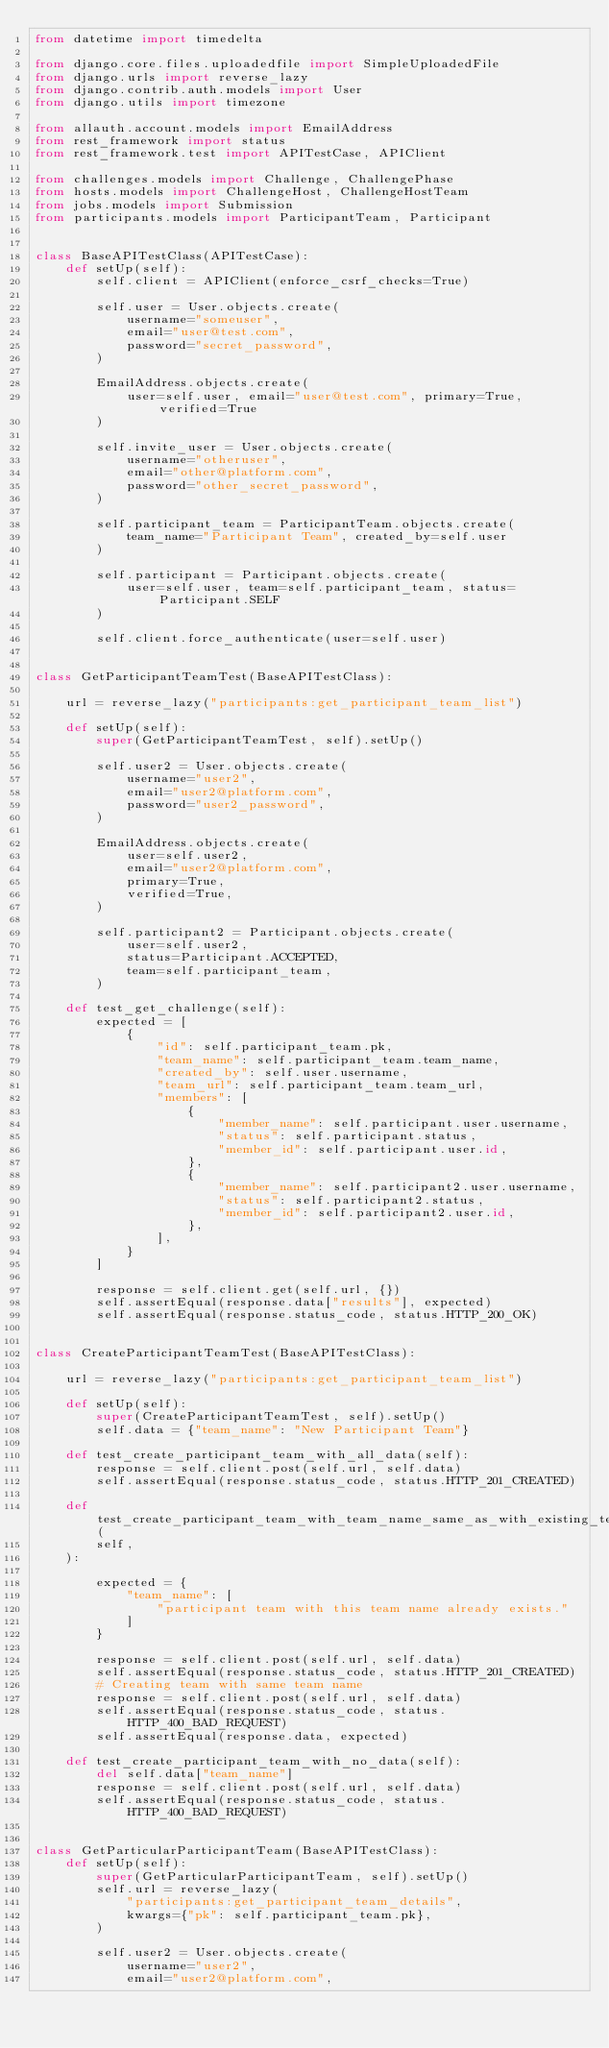Convert code to text. <code><loc_0><loc_0><loc_500><loc_500><_Python_>from datetime import timedelta

from django.core.files.uploadedfile import SimpleUploadedFile
from django.urls import reverse_lazy
from django.contrib.auth.models import User
from django.utils import timezone

from allauth.account.models import EmailAddress
from rest_framework import status
from rest_framework.test import APITestCase, APIClient

from challenges.models import Challenge, ChallengePhase
from hosts.models import ChallengeHost, ChallengeHostTeam
from jobs.models import Submission
from participants.models import ParticipantTeam, Participant


class BaseAPITestClass(APITestCase):
    def setUp(self):
        self.client = APIClient(enforce_csrf_checks=True)

        self.user = User.objects.create(
            username="someuser",
            email="user@test.com",
            password="secret_password",
        )

        EmailAddress.objects.create(
            user=self.user, email="user@test.com", primary=True, verified=True
        )

        self.invite_user = User.objects.create(
            username="otheruser",
            email="other@platform.com",
            password="other_secret_password",
        )

        self.participant_team = ParticipantTeam.objects.create(
            team_name="Participant Team", created_by=self.user
        )

        self.participant = Participant.objects.create(
            user=self.user, team=self.participant_team, status=Participant.SELF
        )

        self.client.force_authenticate(user=self.user)


class GetParticipantTeamTest(BaseAPITestClass):

    url = reverse_lazy("participants:get_participant_team_list")

    def setUp(self):
        super(GetParticipantTeamTest, self).setUp()

        self.user2 = User.objects.create(
            username="user2",
            email="user2@platform.com",
            password="user2_password",
        )

        EmailAddress.objects.create(
            user=self.user2,
            email="user2@platform.com",
            primary=True,
            verified=True,
        )

        self.participant2 = Participant.objects.create(
            user=self.user2,
            status=Participant.ACCEPTED,
            team=self.participant_team,
        )

    def test_get_challenge(self):
        expected = [
            {
                "id": self.participant_team.pk,
                "team_name": self.participant_team.team_name,
                "created_by": self.user.username,
                "team_url": self.participant_team.team_url,
                "members": [
                    {
                        "member_name": self.participant.user.username,
                        "status": self.participant.status,
                        "member_id": self.participant.user.id,
                    },
                    {
                        "member_name": self.participant2.user.username,
                        "status": self.participant2.status,
                        "member_id": self.participant2.user.id,
                    },
                ],
            }
        ]

        response = self.client.get(self.url, {})
        self.assertEqual(response.data["results"], expected)
        self.assertEqual(response.status_code, status.HTTP_200_OK)


class CreateParticipantTeamTest(BaseAPITestClass):

    url = reverse_lazy("participants:get_participant_team_list")

    def setUp(self):
        super(CreateParticipantTeamTest, self).setUp()
        self.data = {"team_name": "New Participant Team"}

    def test_create_participant_team_with_all_data(self):
        response = self.client.post(self.url, self.data)
        self.assertEqual(response.status_code, status.HTTP_201_CREATED)

    def test_create_participant_team_with_team_name_same_as_with_existing_team(
        self,
    ):

        expected = {
            "team_name": [
                "participant team with this team name already exists."
            ]
        }

        response = self.client.post(self.url, self.data)
        self.assertEqual(response.status_code, status.HTTP_201_CREATED)
        # Creating team with same team name
        response = self.client.post(self.url, self.data)
        self.assertEqual(response.status_code, status.HTTP_400_BAD_REQUEST)
        self.assertEqual(response.data, expected)

    def test_create_participant_team_with_no_data(self):
        del self.data["team_name"]
        response = self.client.post(self.url, self.data)
        self.assertEqual(response.status_code, status.HTTP_400_BAD_REQUEST)


class GetParticularParticipantTeam(BaseAPITestClass):
    def setUp(self):
        super(GetParticularParticipantTeam, self).setUp()
        self.url = reverse_lazy(
            "participants:get_participant_team_details",
            kwargs={"pk": self.participant_team.pk},
        )

        self.user2 = User.objects.create(
            username="user2",
            email="user2@platform.com",</code> 